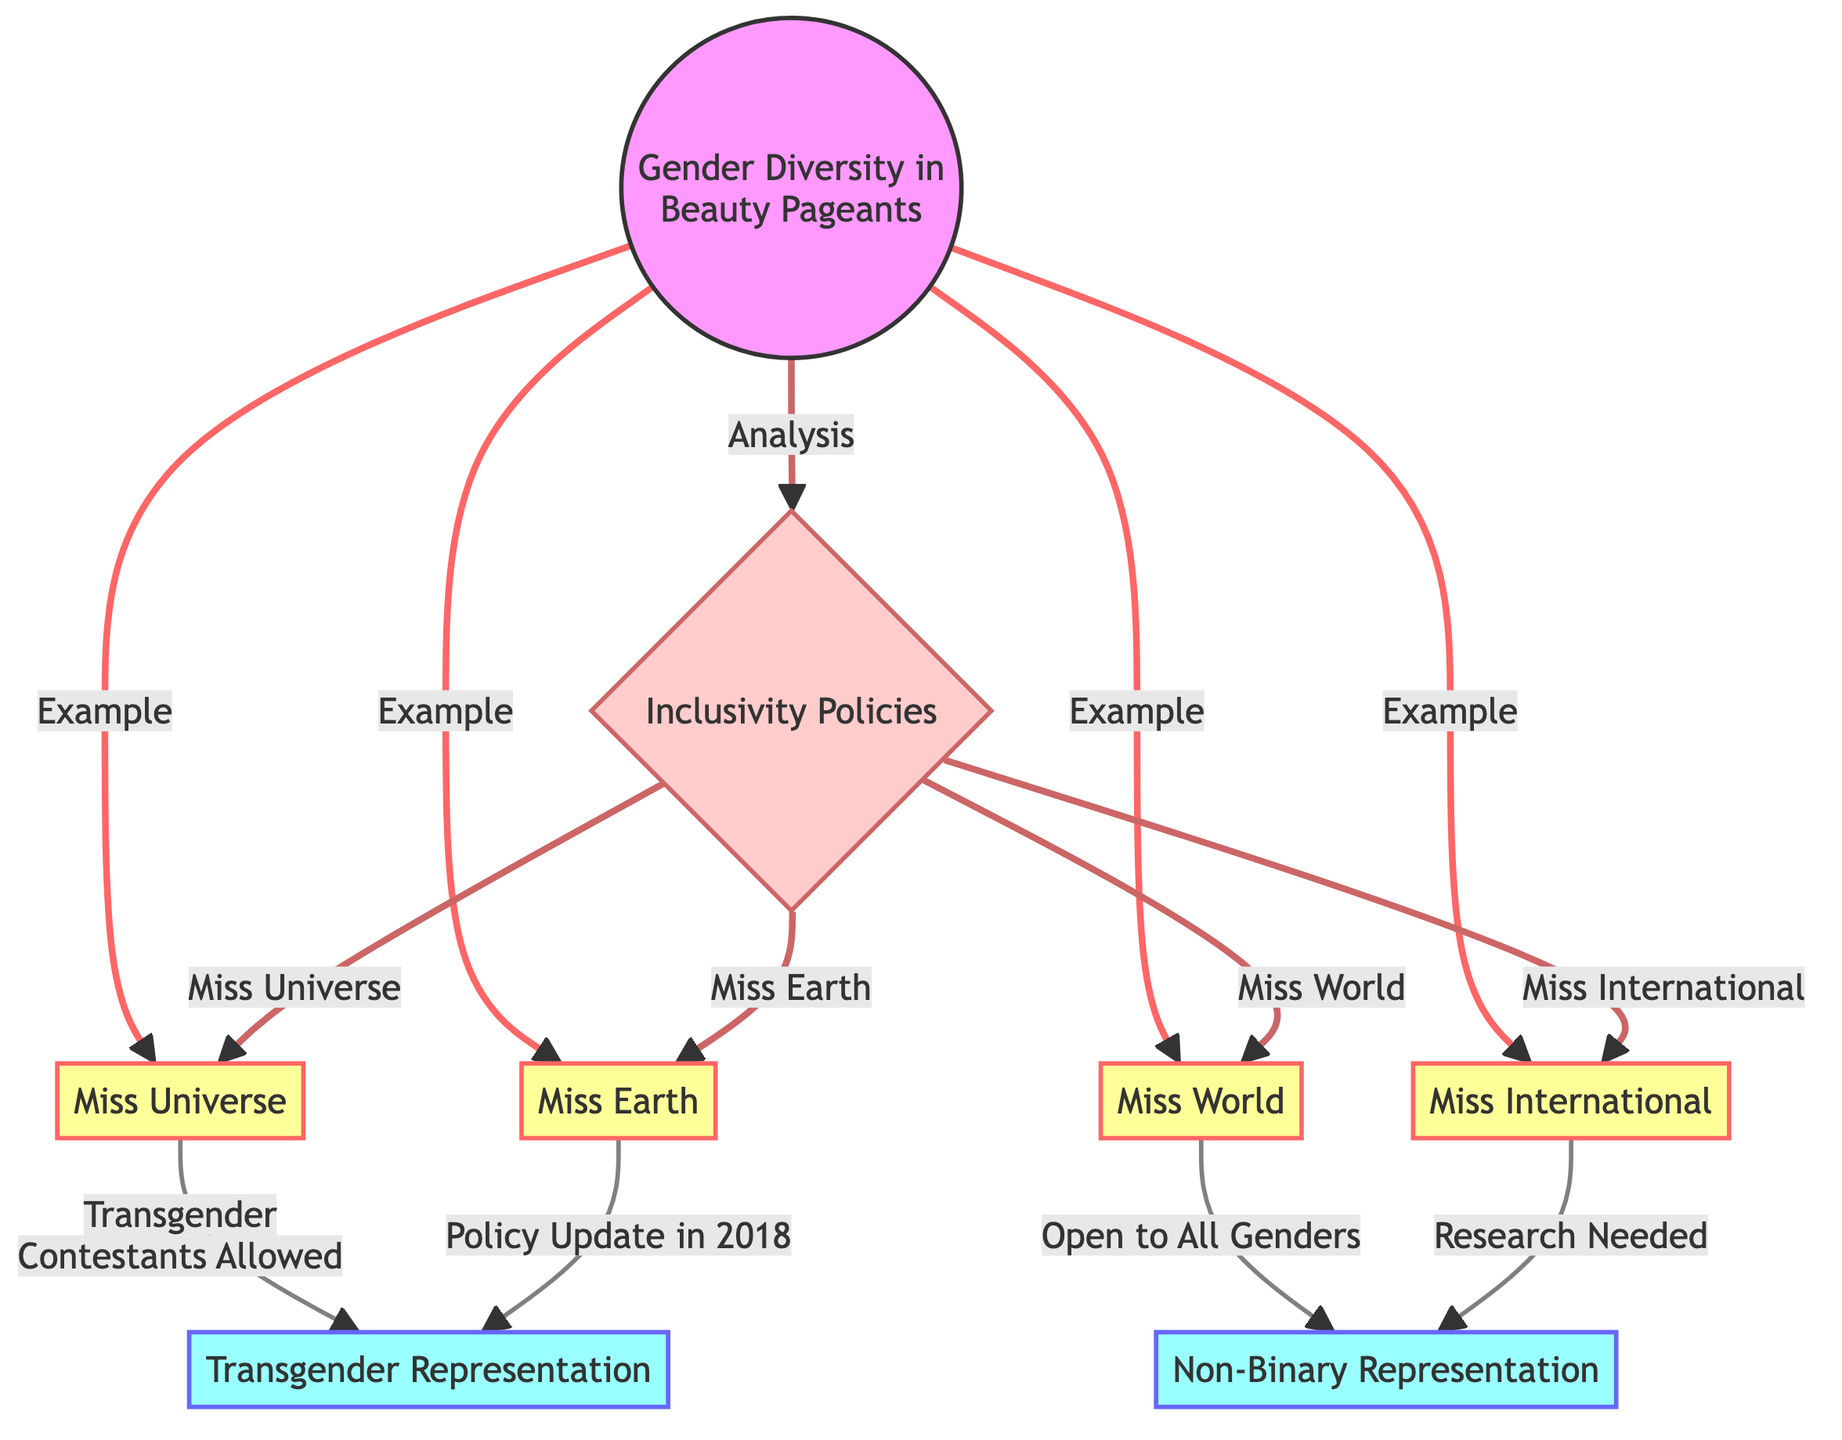What are the four major beauty pageant organizations represented in the diagram? The diagram mentions four major beauty pageant organizations: Miss Universe, Miss World, Miss International, and Miss Earth. These are clearly listed in the diagram under the node titled "Gender Diversity in Beauty Pageants."
Answer: Miss Universe, Miss World, Miss International, Miss Earth How many different types of gender representation are indicated in the diagram? The diagram indicates two types of gender representation: Transgender Representation and Non-Binary Representation, shown under the representation class.
Answer: 2 Which beauty pageant organization allows transgender contestants? According to the diagram, Miss Universe and Miss Earth allow transgender contestants, as indicated in their respective connections in the flowchart.
Answer: Miss Universe, Miss Earth What is a common characteristic of Miss World and Miss International regarding gender diversity? Both Miss World and Miss International have rules that pertain to gender inclusivity; specifically, Miss World is open to all genders, while research is needed for Miss International in regard to non-binary representation.
Answer: Open to all genders, Research needed What does the 'Inclusivity Policies' node connect to? The 'Inclusivity Policies' node connects to all four beauty pageants, indicating that they all have inclusivity policies regarding gender representation. Each pageant is accessible from this node, showing the relationships clearly.
Answer: Miss Universe, Miss World, Miss International, Miss Earth Which beauty pageant organization updated its policy in 2018? The diagram specifies that Miss Earth updated its policy in 2018 regarding transgender representation, as noted in the connection from Miss Earth to the Transgender Representation node.
Answer: Miss Earth What color represents the policy-related elements in the diagram? The color representing policy-related elements in the diagram is a light pinkish color, indicated by the class designation 'policy' which applies to the Inclusivity Policies node.
Answer: Light pink How does the diagram classify the nodes associated with gender representation? The diagram classifies the gender representation nodes under the class 'representation' which is represented by a light blue color, distinguishing it from other categories in the flowchart.
Answer: Light blue 